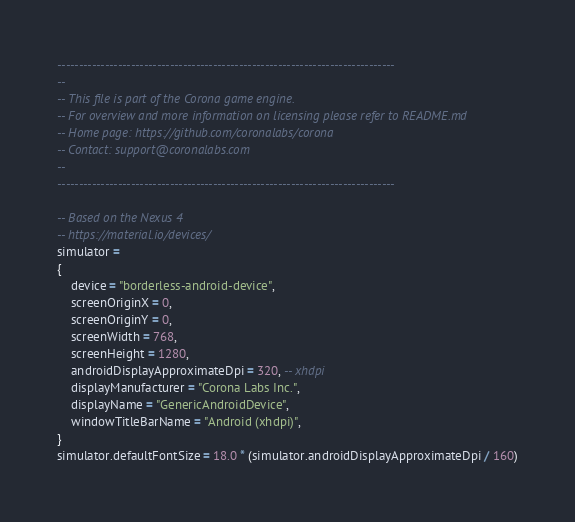<code> <loc_0><loc_0><loc_500><loc_500><_Lua_>------------------------------------------------------------------------------
--
-- This file is part of the Corona game engine.
-- For overview and more information on licensing please refer to README.md 
-- Home page: https://github.com/coronalabs/corona
-- Contact: support@coronalabs.com
--
------------------------------------------------------------------------------

-- Based on the Nexus 4
-- https://material.io/devices/
simulator =
{
	device = "borderless-android-device",
	screenOriginX = 0,
	screenOriginY = 0,
	screenWidth = 768,
	screenHeight = 1280,
	androidDisplayApproximateDpi = 320, -- xhdpi
	displayManufacturer = "Corona Labs Inc.",
	displayName = "GenericAndroidDevice",
	windowTitleBarName = "Android (xhdpi)",
}
simulator.defaultFontSize = 18.0 * (simulator.androidDisplayApproximateDpi / 160)
</code> 